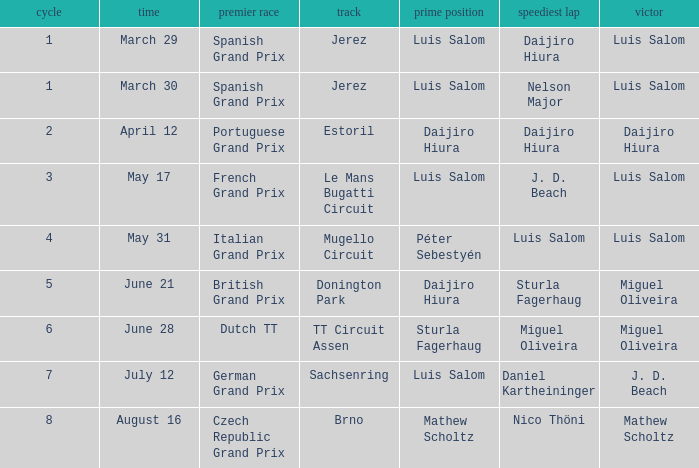Which round 5 Grand Prix had Daijiro Hiura at pole position?  British Grand Prix. 